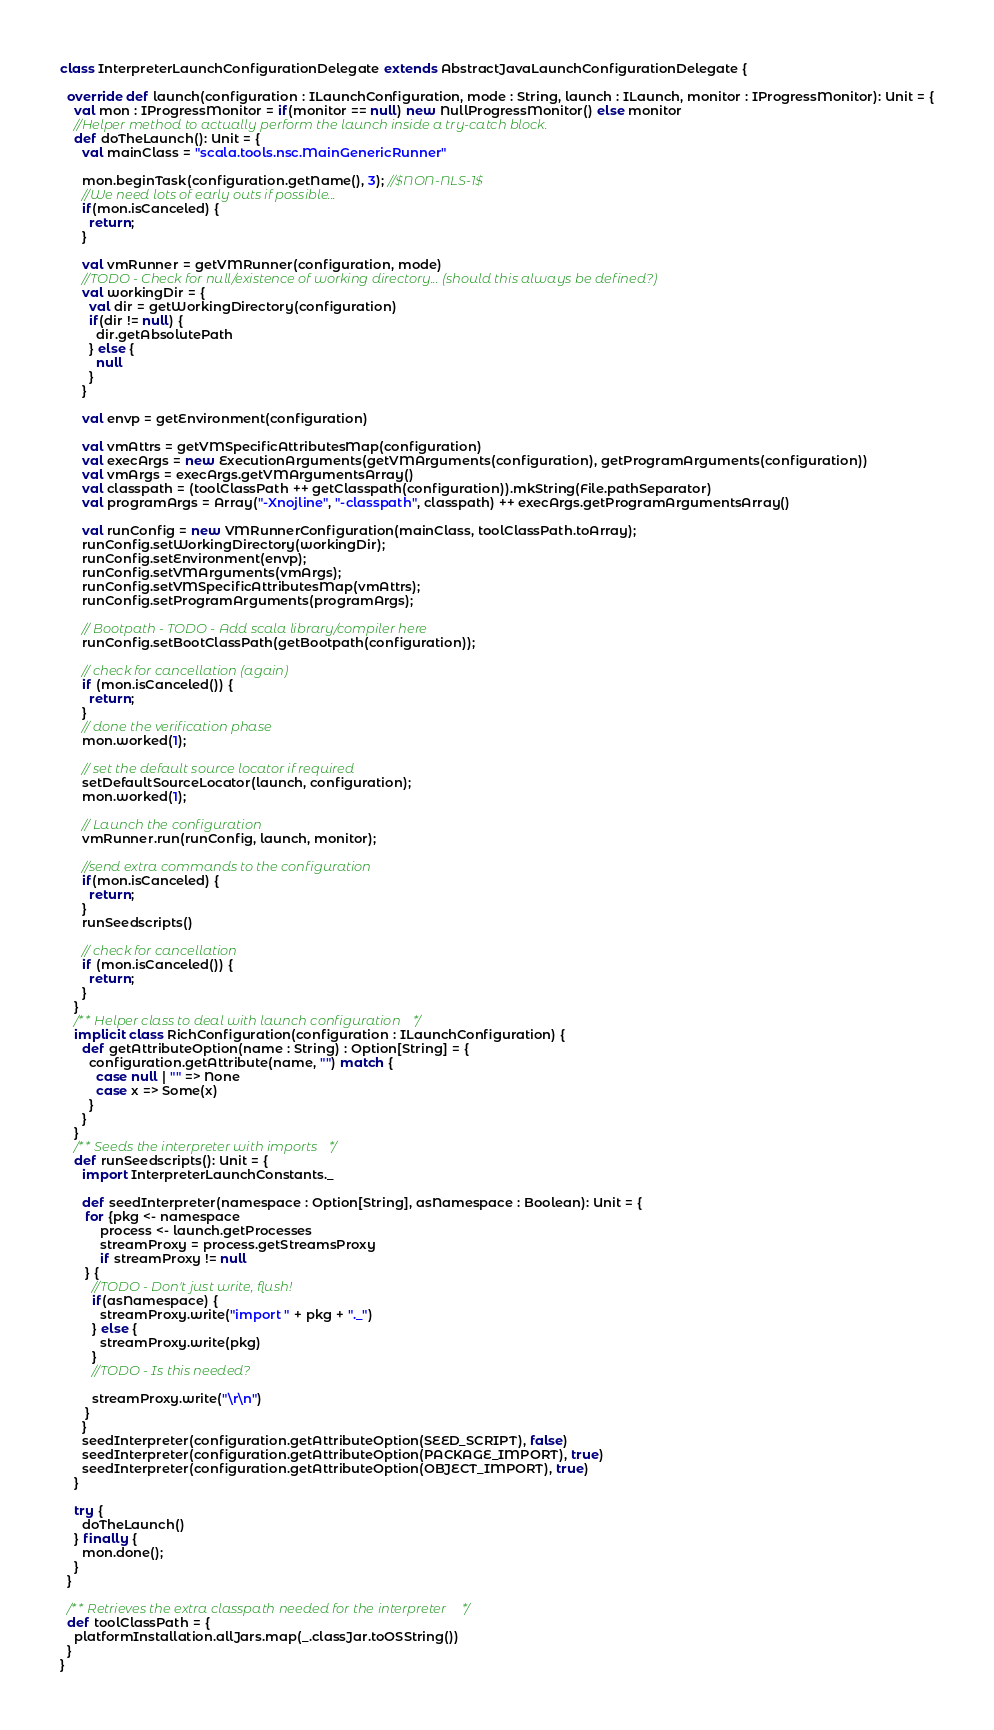Convert code to text. <code><loc_0><loc_0><loc_500><loc_500><_Scala_>class InterpreterLaunchConfigurationDelegate extends AbstractJavaLaunchConfigurationDelegate {

  override def launch(configuration : ILaunchConfiguration, mode : String, launch : ILaunch, monitor : IProgressMonitor): Unit = {
    val mon : IProgressMonitor = if(monitor == null) new NullProgressMonitor() else monitor
    //Helper method to actually perform the launch inside a try-catch block.
    def doTheLaunch(): Unit = {
      val mainClass = "scala.tools.nsc.MainGenericRunner"

      mon.beginTask(configuration.getName(), 3); //$NON-NLS-1$
      //We need lots of early outs if possible...
      if(mon.isCanceled) {
        return;
      }

      val vmRunner = getVMRunner(configuration, mode)
      //TODO - Check for null/existence of working directory... (should this always be defined?)
      val workingDir = {
        val dir = getWorkingDirectory(configuration)
        if(dir != null) {
          dir.getAbsolutePath
        } else {
          null
        }
      }

      val envp = getEnvironment(configuration)

      val vmAttrs = getVMSpecificAttributesMap(configuration)
      val execArgs = new ExecutionArguments(getVMArguments(configuration), getProgramArguments(configuration))
      val vmArgs = execArgs.getVMArgumentsArray()
      val classpath = (toolClassPath ++ getClasspath(configuration)).mkString(File.pathSeparator)
      val programArgs = Array("-Xnojline", "-classpath", classpath) ++ execArgs.getProgramArgumentsArray()

      val runConfig = new VMRunnerConfiguration(mainClass, toolClassPath.toArray);
      runConfig.setWorkingDirectory(workingDir);
      runConfig.setEnvironment(envp);
      runConfig.setVMArguments(vmArgs);
      runConfig.setVMSpecificAttributesMap(vmAttrs);
      runConfig.setProgramArguments(programArgs);

      // Bootpath - TODO - Add scala library/compiler here
      runConfig.setBootClassPath(getBootpath(configuration));

      // check for cancellation (again)
      if (mon.isCanceled()) {
        return;
      }
      // done the verification phase
      mon.worked(1);

      // set the default source locator if required
      setDefaultSourceLocator(launch, configuration);
      mon.worked(1);

      // Launch the configuration
      vmRunner.run(runConfig, launch, monitor);

      //send extra commands to the configuration
      if(mon.isCanceled) {
        return;
      }
      runSeedscripts()

      // check for cancellation
      if (mon.isCanceled()) {
        return;
      }
    }
    /** Helper class to deal with launch configuration */
    implicit class RichConfiguration(configuration : ILaunchConfiguration) {
      def getAttributeOption(name : String) : Option[String] = {
        configuration.getAttribute(name, "") match {
          case null | "" => None
          case x => Some(x)
        }
      }
    }
    /** Seeds the interpreter with imports */
    def runSeedscripts(): Unit = {
      import InterpreterLaunchConstants._

      def seedInterpreter(namespace : Option[String], asNamespace : Boolean): Unit = {
       for {pkg <- namespace
           process <- launch.getProcesses
           streamProxy = process.getStreamsProxy
           if streamProxy != null
       } {
         //TODO - Don't just write, flush!
         if(asNamespace) {
           streamProxy.write("import " + pkg + "._")
         } else {
           streamProxy.write(pkg)
         }
         //TODO - Is this needed?

         streamProxy.write("\r\n")
       }
      }
      seedInterpreter(configuration.getAttributeOption(SEED_SCRIPT), false)
      seedInterpreter(configuration.getAttributeOption(PACKAGE_IMPORT), true)
      seedInterpreter(configuration.getAttributeOption(OBJECT_IMPORT), true)
    }

    try {
      doTheLaunch()
    } finally {
      mon.done();
    }
  }

  /** Retrieves the extra classpath needed for the interpreter*/
  def toolClassPath = {
    platformInstallation.allJars.map(_.classJar.toOSString())
  }
}
</code> 